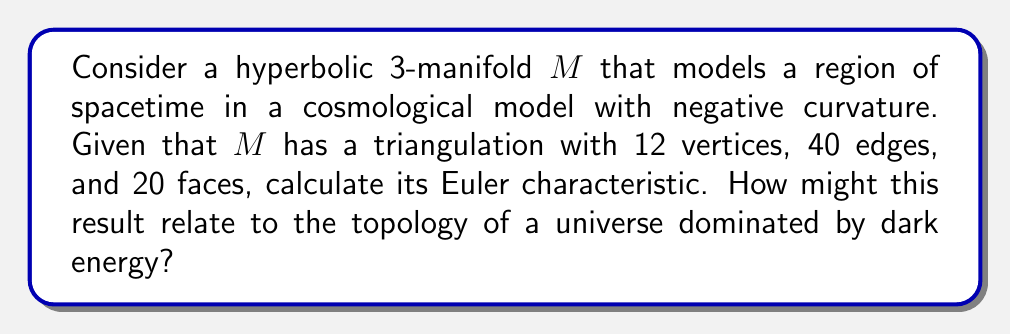Teach me how to tackle this problem. To solve this problem, we'll follow these steps:

1) Recall the definition of the Euler characteristic for a 3-manifold:
   
   The Euler characteristic $\chi(M)$ of a 3-manifold $M$ is given by:
   
   $$\chi(M) = V - E + F - T$$
   
   where $V$ is the number of vertices, $E$ is the number of edges, $F$ is the number of faces, and $T$ is the number of tetrahedra in a triangulation of $M$.

2) From the given information:
   $V = 12$
   $E = 40$
   $F = 20$
   
   We need to determine $T$.

3) In a closed 3-manifold, each tetrahedron has 4 faces, and each face belongs to exactly 2 tetrahedra. Therefore:
   
   $$4T = 2F$$
   $$T = \frac{F}{2} = \frac{20}{2} = 10$$

4) Now we can calculate the Euler characteristic:
   
   $$\chi(M) = V - E + F - T$$
   $$\chi(M) = 12 - 40 + 20 - 10 = -18$$

5) Relating to dark energy and cosmology:
   The negative Euler characteristic suggests that $M$ has a non-trivial topology. In cosmological models, a hyperbolic 3-manifold with negative Euler characteristic could represent a universe with negative curvature, which is consistent with the observed acceleration of the universe's expansion attributed to dark energy. The non-zero Euler characteristic also implies that the manifold is not simply connected, suggesting potential large-scale topological structure in such a universe.
Answer: The Euler characteristic of the given hyperbolic 3-manifold is $\chi(M) = -18$. 